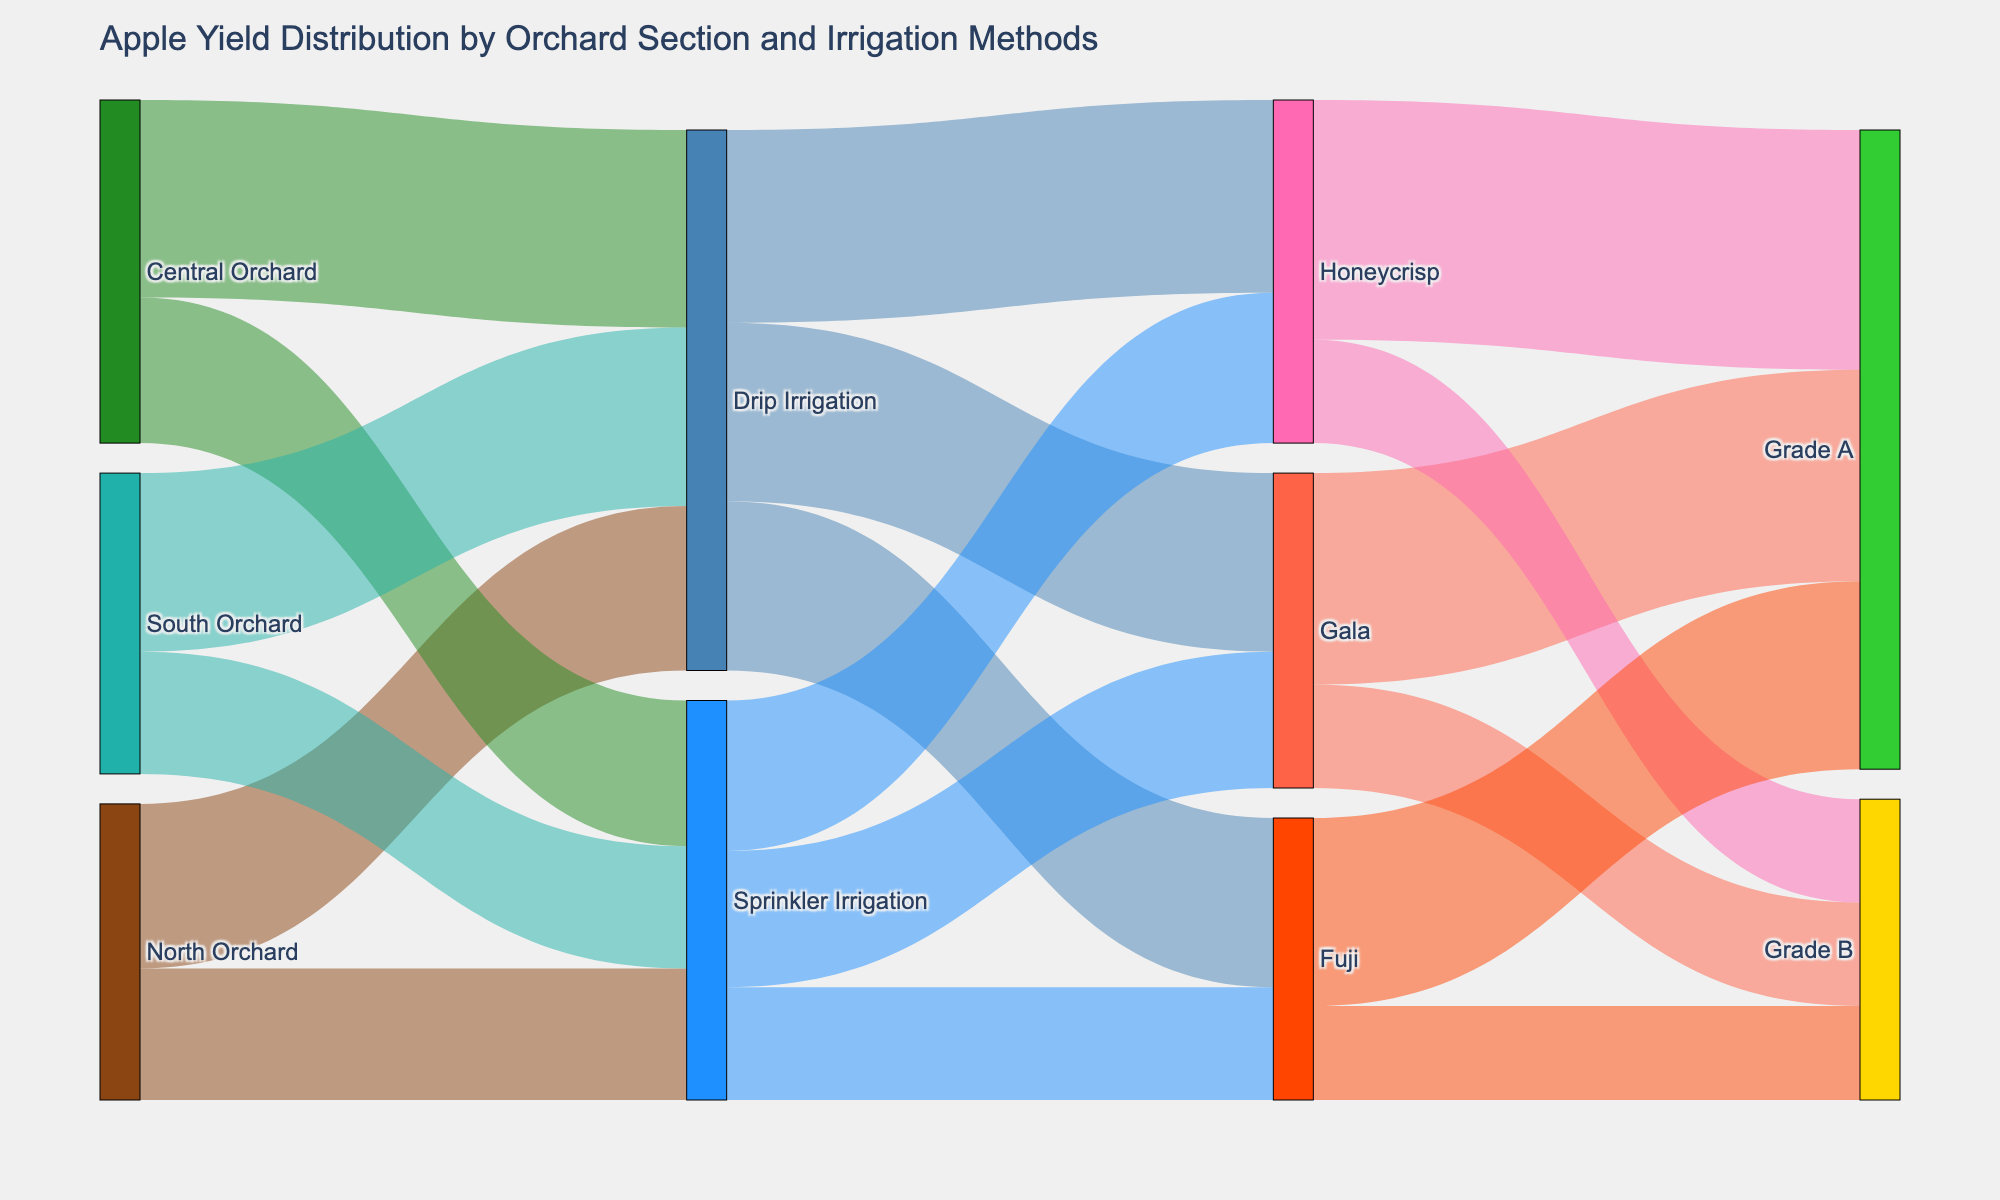How many total apples did the North Orchard produce? From the figure, we see that North Orchard connects to Drip Irrigation with 3500 apples and Sprinkler Irrigation with 2800 apples. Summing these up gives 3500 + 2800 = 6300.
Answer: 6300 How many Grade A apples were harvested from Gala apples? The Sankey diagram shows the flow from Gala to Grade A, with a value of 4500 apples.
Answer: 4500 Which orchard section contributed the most apples to Drip Irrigation? By comparing the values leading to Drip Irrigation, the Central Orchard contributed 4200 apples, North Orchard 3500, and South Orchard 3800. The Central Orchard has the highest contribution.
Answer: Central Orchard How many Gala apples were produced by Sprinkler Irrigation? The diagram shows a connection from Sprinkler Irrigation to Gala with a value of 2900 apples.
Answer: 2900 How many total Grade B apples were harvested? The Grade B category gets apples from Gala, Honeycrisp, and Fuji. Summing their values: 2200 (Gala) + 2200 (Honeycrisp) + 2000 (Fuji) = 6400.
Answer: 6400 Which irrigation method produced more Fuji apples? Drip Irrigation produced 3600 Fuji apples, while Sprinkler Irrigation produced 2400. Drip Irrigation produced more.
Answer: Drip Irrigation How many total apples were harvested using Sprinkler Irrigation? Combining apples going from Sprinkler Irrigation to Gala, Honeycrisp, and Fuji: 2900 + 3200 + 2400 = 8500.
Answer: 8500 What is the difference in the number of apples produced by Drip Irrigation and Sprinkler Irrigation for Honeycrisp apples? Drip Irrigation produced 4100 Honeycrisp apples and Sprinkler Irrigation produced 3200. The difference is 4100 - 3200 = 900.
Answer: 900 Which variety of apples had the most Grade B apples? Gala, Honeycrisp, and Fuji had Grade B apples. Both Gala and Honeycrisp had 2200, while Fuji had 2000. Gala and Honeycrisp produced the most.
Answer: Gala and Honeycrisp How many more apples did Honeycrisp produce compared to Fuji across all irrigation methods? Total Honeycrisp apples are 4100 (Drip) + 3200 (Sprinkler) = 7300. Total Fuji apples are 3600 (Drip) + 2400 (Sprinkler) = 6000. The difference is 7300 - 6000 = 1300.
Answer: 1300 